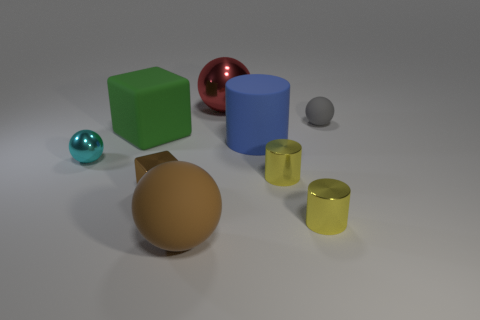Subtract all big red balls. How many balls are left? 3 Subtract 2 cylinders. How many cylinders are left? 1 Subtract all cyan blocks. How many yellow cylinders are left? 2 Subtract all gray balls. How many balls are left? 3 Subtract all cubes. How many objects are left? 7 Subtract all gray spheres. Subtract all green cylinders. How many spheres are left? 3 Subtract all large gray rubber spheres. Subtract all large blue matte objects. How many objects are left? 8 Add 9 rubber cylinders. How many rubber cylinders are left? 10 Add 5 tiny brown metal things. How many tiny brown metal things exist? 6 Subtract 0 red cylinders. How many objects are left? 9 